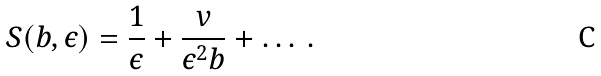<formula> <loc_0><loc_0><loc_500><loc_500>\, S ( b , \epsilon ) = \frac { 1 } { \epsilon } + \frac { v } { \epsilon ^ { 2 } b } + \dots \, .</formula> 